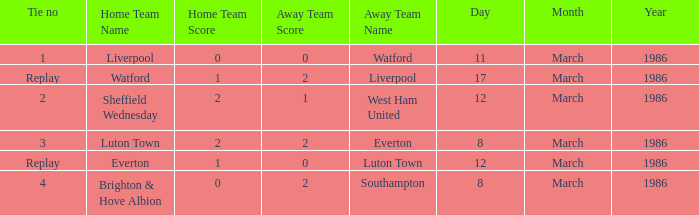What was the tie resulting from Sheffield Wednesday's game? 2.0. 